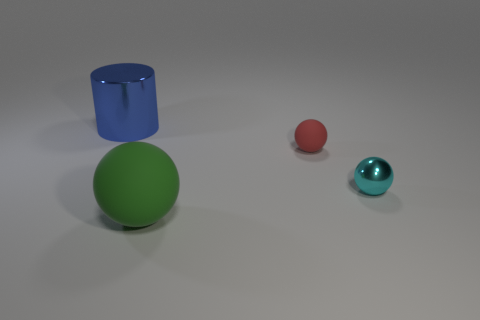How many matte things are green spheres or blue objects? In the image, there is one large green sphere and one smaller blue cylinder. Both objects appear to have a matte finish. Therefore, there are two matte objects corresponding to the criteria: one green sphere and one blue object. 